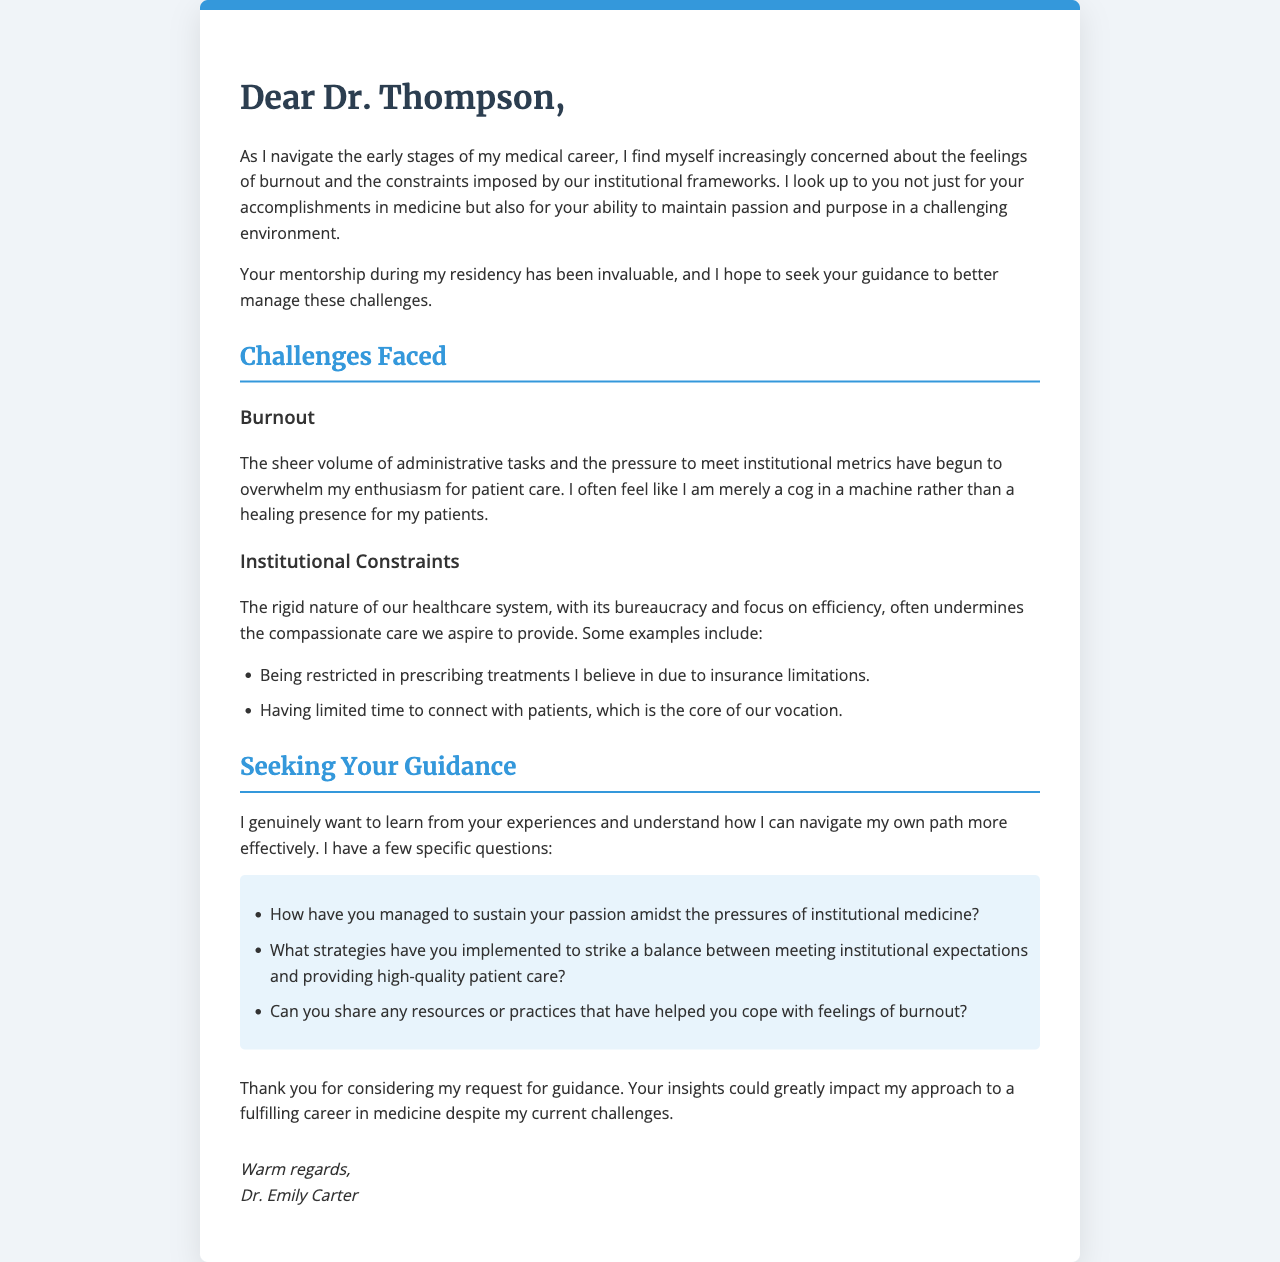What is the name of the recipient? The letter is addressed to Dr. Thompson, who is the mentor of the author.
Answer: Dr. Thompson Who is the author of the letter? The closing of the letter identifies the author as Dr. Emily Carter.
Answer: Dr. Emily Carter What are the two main challenges mentioned in the letter? The letter highlights burnout and institutional constraints as the two primary challenges faced by the author.
Answer: Burnout, institutional constraints List one example of institutional constraints mentioned. The document provides an example related to prescribing treatments due to insurance limitations.
Answer: Insurance limitations How many specific questions does the author ask for guidance? The author lists three specific questions in the section seeking guidance.
Answer: Three What is the main purpose of the letter? The purpose is to seek guidance from a mentor on navigating career challenges and maintaining passion for medicine.
Answer: Seeking guidance What emotion does the author express regarding their current position in medicine? The author expresses feelings of being overwhelmed and trapped within the institutional framework.
Answer: Overwhelmed What formatting style is used for the title of the letter? The title, "Dear Dr. Thompson," is presented in a larger font and bold style that distinguishes it from the rest of the text.
Answer: Larger font and bold style 